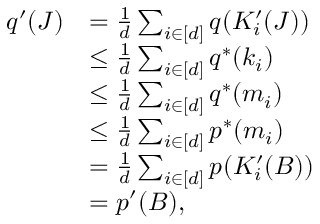Convert formula to latex. <formula><loc_0><loc_0><loc_500><loc_500>\begin{array} { r l } { q ^ { \prime } ( J ) } & { = \frac { 1 } d \sum _ { i \in [ d ] } q ( K _ { i } ^ { \prime } ( J ) ) } \\ & { \leq \frac { 1 } d \sum _ { i \in [ d ] } q ^ { * } ( k _ { i } ) } \\ & { \leq \frac { 1 } d \sum _ { i \in [ d ] } q ^ { * } ( m _ { i } ) } \\ & { \leq \frac { 1 } d \sum _ { i \in [ d ] } p ^ { * } ( m _ { i } ) } \\ & { = \frac { 1 } d \sum _ { i \in [ d ] } p ( K _ { i } ^ { \prime } ( B ) ) } \\ & { = p ^ { \prime } ( B ) , } \end{array}</formula> 